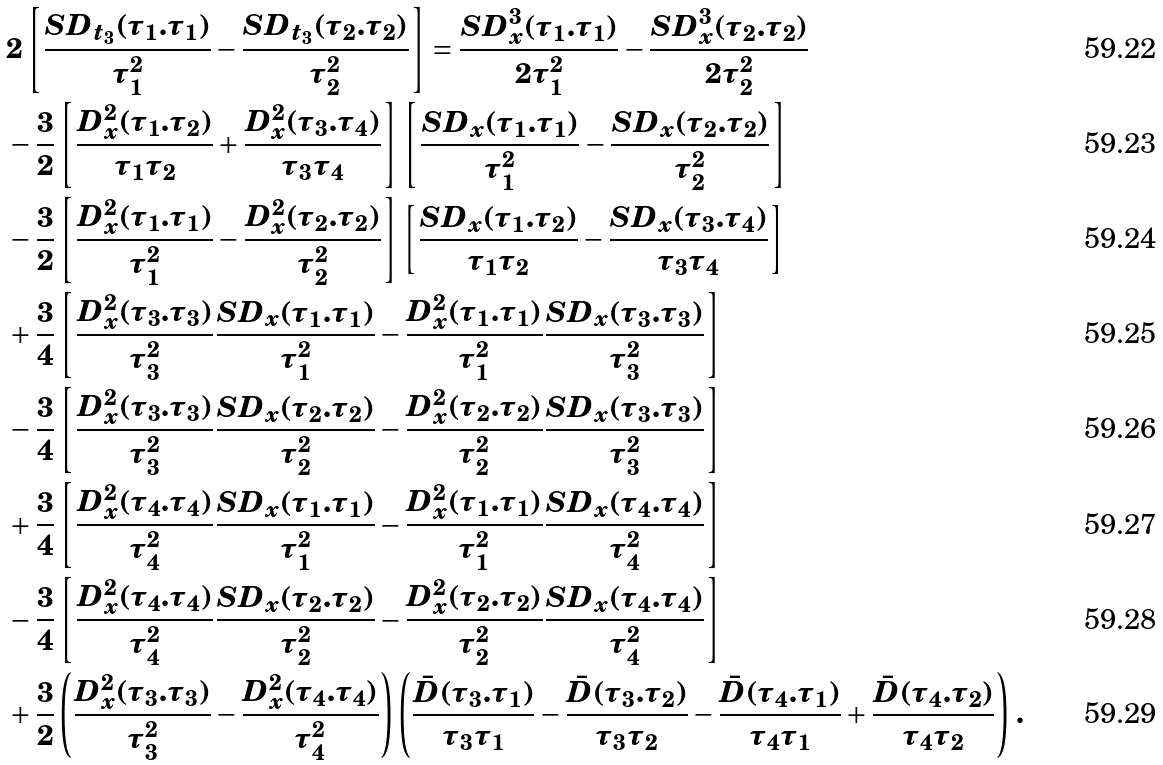Convert formula to latex. <formula><loc_0><loc_0><loc_500><loc_500>& 2 \left [ \frac { { S D } _ { t _ { 3 } } ( \tau _ { 1 } . \tau _ { 1 } ) } { \tau _ { 1 } ^ { 2 } } - \frac { { S D } _ { t _ { 3 } } ( \tau _ { 2 } . \tau _ { 2 } ) } { \tau _ { 2 } ^ { 2 } } \right ] = \frac { { S D } _ { x } ^ { 3 } ( \tau _ { 1 } . \tau _ { 1 } ) } { 2 \tau _ { 1 } ^ { 2 } } - \frac { { S D } _ { x } ^ { 3 } ( \tau _ { 2 } . \tau _ { 2 } ) } { 2 \tau _ { 2 } ^ { 2 } } \\ & - \frac { 3 } { 2 } \left [ \frac { { D } _ { x } ^ { 2 } ( \tau _ { 1 } . \tau _ { 2 } ) } { \tau _ { 1 } \tau _ { 2 } } + \frac { { D } _ { x } ^ { 2 } ( \tau _ { 3 } . \tau _ { 4 } ) } { \tau _ { 3 } \tau _ { 4 } } \right ] \left [ \frac { { S D } _ { x } ( \tau _ { 1 } . \tau _ { 1 } ) } { \tau _ { 1 } ^ { 2 } } - \frac { { S D } _ { x } ( \tau _ { 2 } . \tau _ { 2 } ) } { \tau _ { 2 } ^ { 2 } } \right ] \\ & - \frac { 3 } { 2 } \left [ \frac { { D } _ { x } ^ { 2 } ( \tau _ { 1 } . \tau _ { 1 } ) } { \tau _ { 1 } ^ { 2 } } - \frac { { D } _ { x } ^ { 2 } ( \tau _ { 2 } . \tau _ { 2 } ) } { \tau _ { 2 } ^ { 2 } } \right ] \left [ \frac { { S D } _ { x } ( \tau _ { 1 } . \tau _ { 2 } ) } { \tau _ { 1 } \tau _ { 2 } } - \frac { { S D } _ { x } ( \tau _ { 3 } . \tau _ { 4 } ) } { \tau _ { 3 } \tau _ { 4 } } \right ] \\ & + \frac { 3 } { 4 } \left [ \frac { { D } _ { x } ^ { 2 } ( \tau _ { 3 } . \tau _ { 3 } ) } { \tau _ { 3 } ^ { 2 } } \frac { { S D } _ { x } ( \tau _ { 1 } . \tau _ { 1 } ) } { \tau _ { 1 } ^ { 2 } } - \frac { { D } _ { x } ^ { 2 } ( \tau _ { 1 } . \tau _ { 1 } ) } { \tau _ { 1 } ^ { 2 } } \frac { { S D } _ { x } ( \tau _ { 3 } . \tau _ { 3 } ) } { \tau _ { 3 } ^ { 2 } } \right ] \\ & - \frac { 3 } { 4 } \left [ \frac { { D } _ { x } ^ { 2 } ( \tau _ { 3 } . \tau _ { 3 } ) } { \tau _ { 3 } ^ { 2 } } \frac { { S D } _ { x } ( \tau _ { 2 } . \tau _ { 2 } ) } { \tau _ { 2 } ^ { 2 } } - \frac { { D } _ { x } ^ { 2 } ( \tau _ { 2 } . \tau _ { 2 } ) } { \tau _ { 2 } ^ { 2 } } \frac { { S D } _ { x } ( \tau _ { 3 } . \tau _ { 3 } ) } { \tau _ { 3 } ^ { 2 } } \right ] \\ & + \frac { 3 } { 4 } \left [ \frac { { D } _ { x } ^ { 2 } ( \tau _ { 4 } . \tau _ { 4 } ) } { \tau _ { 4 } ^ { 2 } } \frac { { S D } _ { x } ( \tau _ { 1 } . \tau _ { 1 } ) } { \tau _ { 1 } ^ { 2 } } - \frac { { D } _ { x } ^ { 2 } ( \tau _ { 1 } . \tau _ { 1 } ) } { \tau _ { 1 } ^ { 2 } } \frac { { S D } _ { x } ( \tau _ { 4 } . \tau _ { 4 } ) } { \tau _ { 4 } ^ { 2 } } \right ] \\ & - \frac { 3 } { 4 } \left [ \frac { { D } _ { x } ^ { 2 } ( \tau _ { 4 } . \tau _ { 4 } ) } { \tau _ { 4 } ^ { 2 } } \frac { { S D } _ { x } ( \tau _ { 2 } . \tau _ { 2 } ) } { \tau _ { 2 } ^ { 2 } } - \frac { { D } _ { x } ^ { 2 } ( \tau _ { 2 } . \tau _ { 2 } ) } { \tau _ { 2 } ^ { 2 } } \frac { { S D } _ { x } ( \tau _ { 4 } . \tau _ { 4 } ) } { \tau _ { 4 } ^ { 2 } } \right ] \\ & + \frac { 3 } { 2 } \left ( \frac { { D } _ { x } ^ { 2 } ( \tau _ { 3 } . \tau _ { 3 } ) } { \tau _ { 3 } ^ { 2 } } - \frac { { D } _ { x } ^ { 2 } ( \tau _ { 4 } . \tau _ { 4 } ) } { \tau _ { 4 } ^ { 2 } } \right ) \left ( \frac { \bar { D } ( \tau _ { 3 } . \tau _ { 1 } ) } { \tau _ { 3 } \tau _ { 1 } } - \frac { \bar { D } ( \tau _ { 3 } . \tau _ { 2 } ) } { \tau _ { 3 } \tau _ { 2 } } - \frac { \bar { D } ( \tau _ { 4 } . \tau _ { 1 } ) } { \tau _ { 4 } \tau _ { 1 } } + \frac { \bar { D } ( \tau _ { 4 } . \tau _ { 2 } ) } { \tau _ { 4 } \tau _ { 2 } } \right ) \, .</formula> 